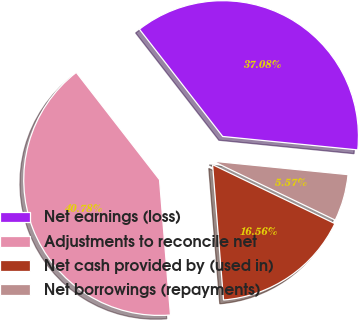Convert chart. <chart><loc_0><loc_0><loc_500><loc_500><pie_chart><fcel>Net earnings (loss)<fcel>Adjustments to reconcile net<fcel>Net cash provided by (used in)<fcel>Net borrowings (repayments)<nl><fcel>37.08%<fcel>40.78%<fcel>16.56%<fcel>5.57%<nl></chart> 